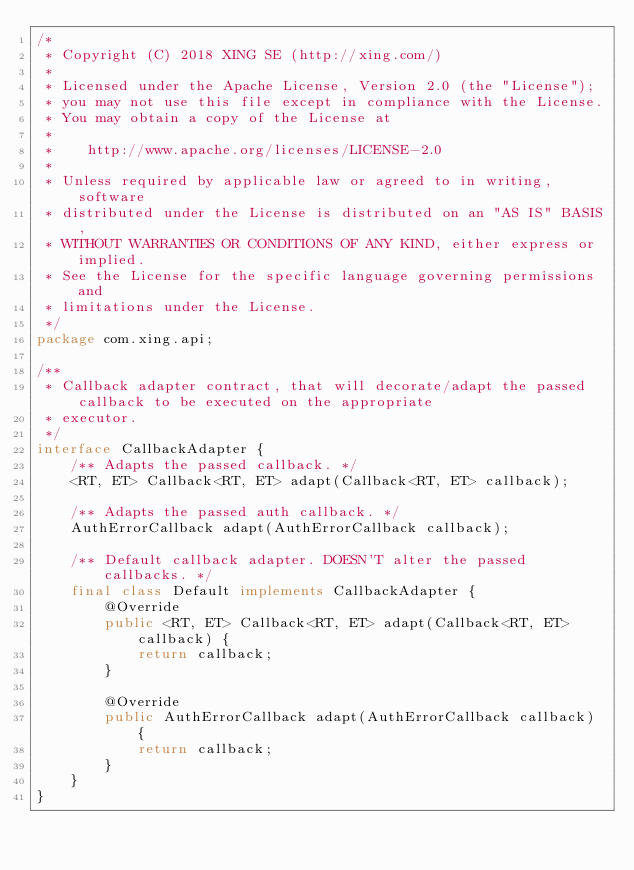<code> <loc_0><loc_0><loc_500><loc_500><_Java_>/*
 * Copyright (C) 2018 XING SE (http://xing.com/)
 *
 * Licensed under the Apache License, Version 2.0 (the "License");
 * you may not use this file except in compliance with the License.
 * You may obtain a copy of the License at
 *
 *    http://www.apache.org/licenses/LICENSE-2.0
 *
 * Unless required by applicable law or agreed to in writing, software
 * distributed under the License is distributed on an "AS IS" BASIS,
 * WITHOUT WARRANTIES OR CONDITIONS OF ANY KIND, either express or implied.
 * See the License for the specific language governing permissions and
 * limitations under the License.
 */
package com.xing.api;

/**
 * Callback adapter contract, that will decorate/adapt the passed callback to be executed on the appropriate
 * executor.
 */
interface CallbackAdapter {
    /** Adapts the passed callback. */
    <RT, ET> Callback<RT, ET> adapt(Callback<RT, ET> callback);

    /** Adapts the passed auth callback. */
    AuthErrorCallback adapt(AuthErrorCallback callback);

    /** Default callback adapter. DOESN'T alter the passed callbacks. */
    final class Default implements CallbackAdapter {
        @Override
        public <RT, ET> Callback<RT, ET> adapt(Callback<RT, ET> callback) {
            return callback;
        }

        @Override
        public AuthErrorCallback adapt(AuthErrorCallback callback) {
            return callback;
        }
    }
}
</code> 